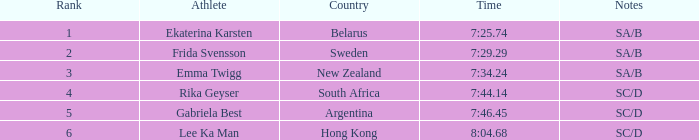Can you parse all the data within this table? {'header': ['Rank', 'Athlete', 'Country', 'Time', 'Notes'], 'rows': [['1', 'Ekaterina Karsten', 'Belarus', '7:25.74', 'SA/B'], ['2', 'Frida Svensson', 'Sweden', '7:29.29', 'SA/B'], ['3', 'Emma Twigg', 'New Zealand', '7:34.24', 'SA/B'], ['4', 'Rika Geyser', 'South Africa', '7:44.14', 'SC/D'], ['5', 'Gabriela Best', 'Argentina', '7:46.45', 'SC/D'], ['6', 'Lee Ka Man', 'Hong Kong', '8:04.68', 'SC/D']]} What is the race time for emma twigg? 7:34.24. 